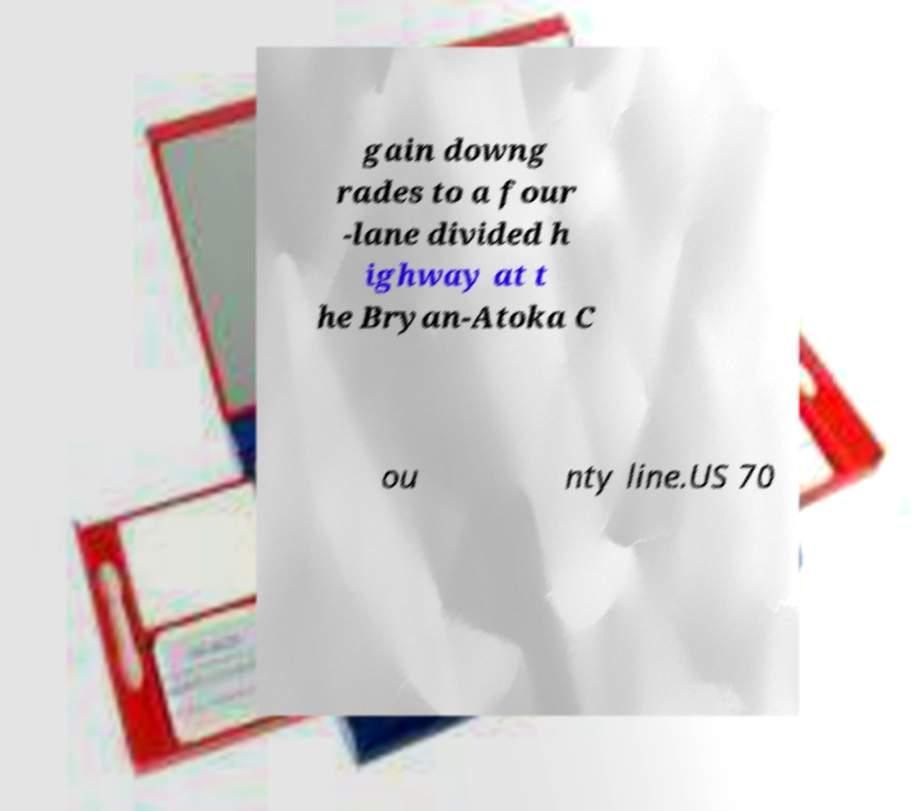Can you accurately transcribe the text from the provided image for me? gain downg rades to a four -lane divided h ighway at t he Bryan-Atoka C ou nty line.US 70 